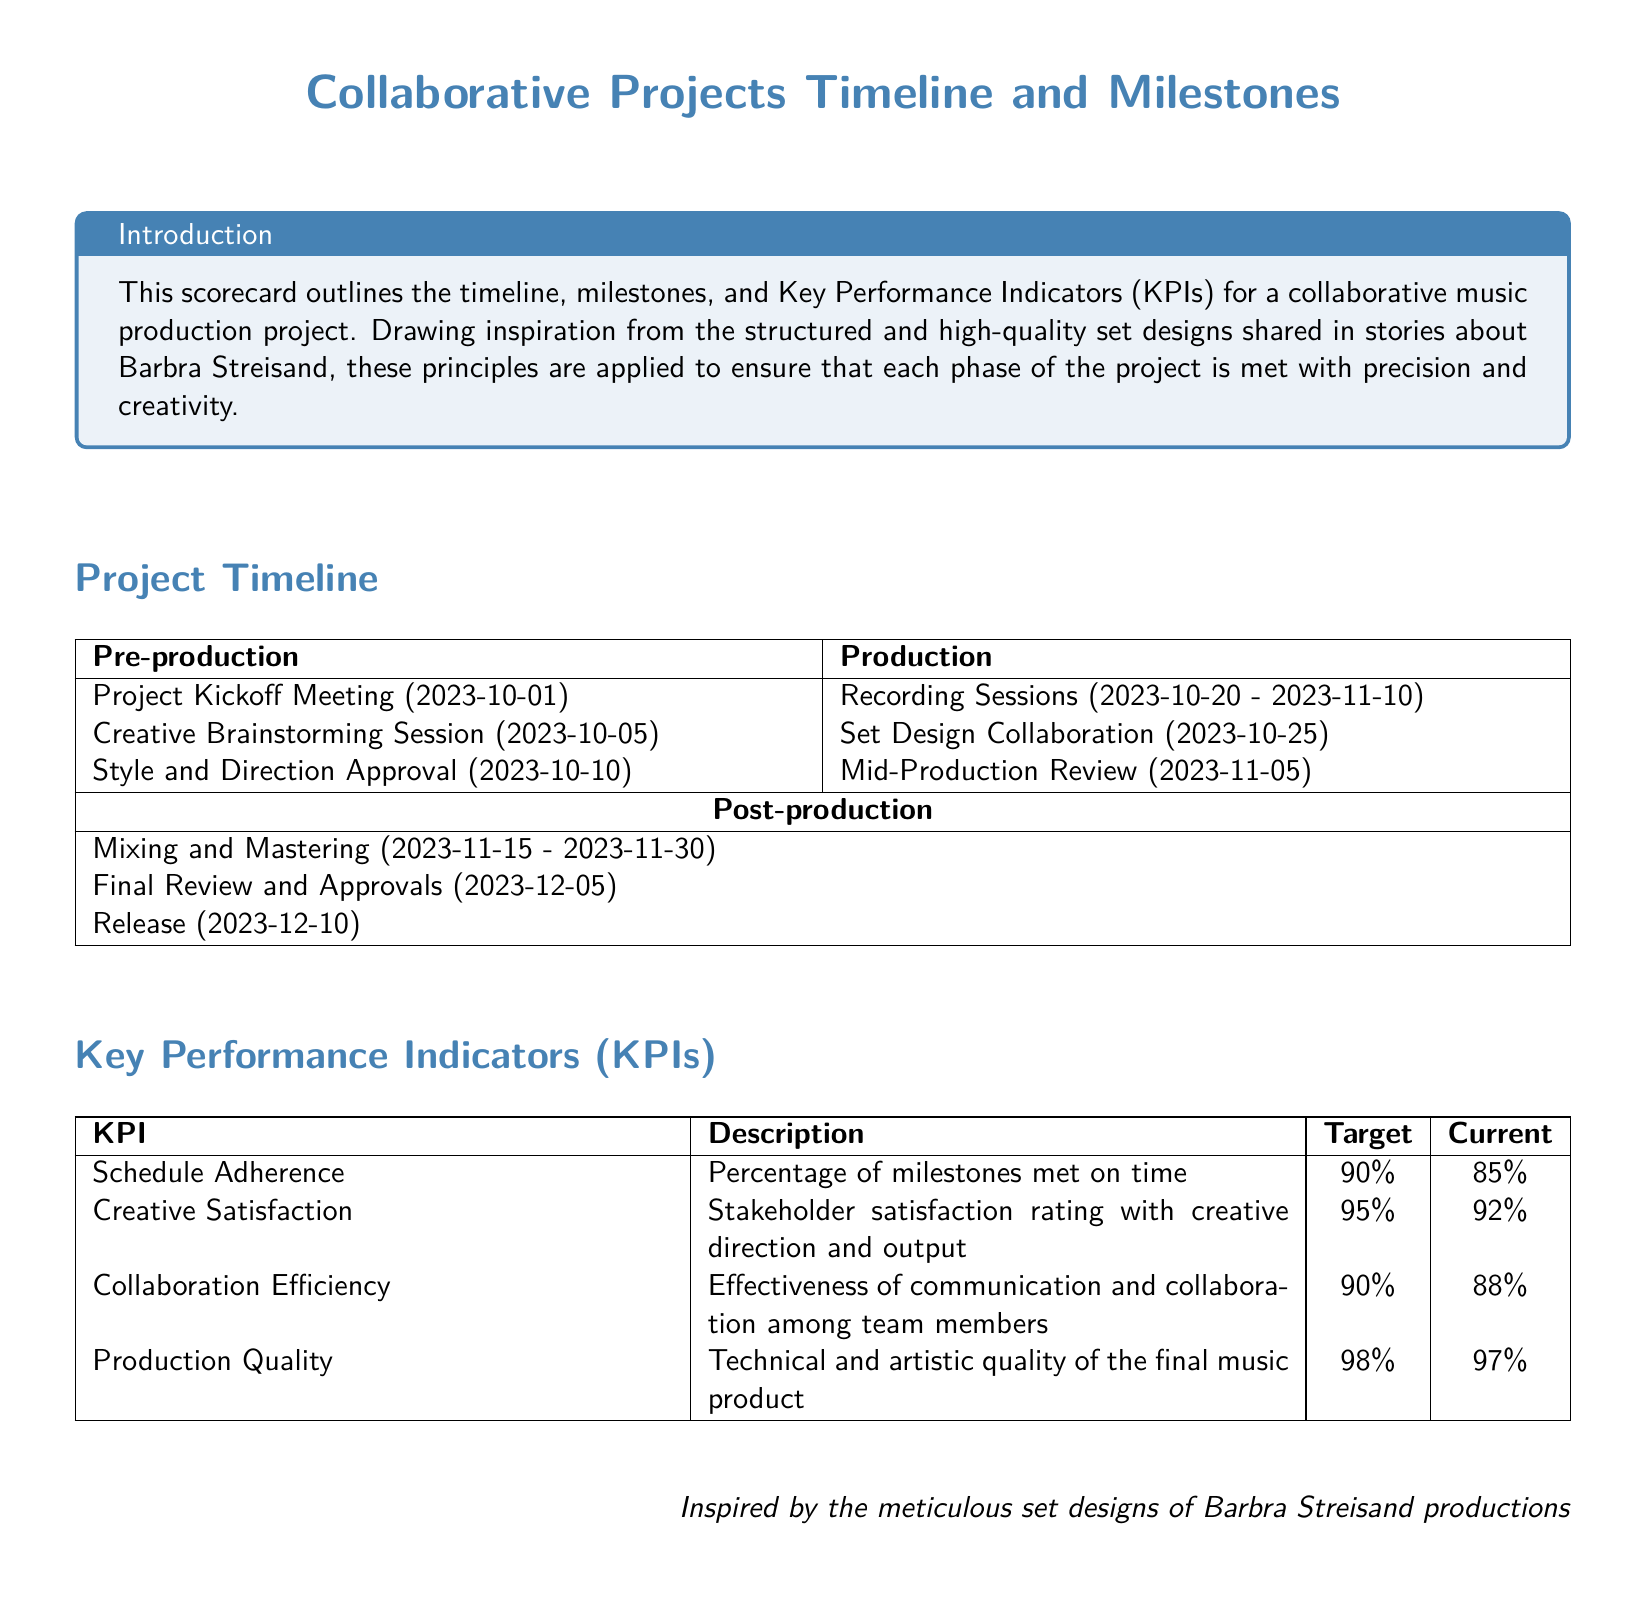What is the date of the project kickoff meeting? The date for the project kickoff meeting is specified in the document.
Answer: 2023-10-01 What phase follows the pre-production phase? The document outlines the sequence of phases in the project timeline, showing that after pre-production comes production.
Answer: Production What is the target percentage for schedule adherence? The target percentage for schedule adherence is listed in the KPI table of the document.
Answer: 90% What is the current creative satisfaction percentage? The current creative satisfaction percentage is found in the KPIs section of the document.
Answer: 92% When is the final review and approvals scheduled? The document contains specific dates for all major milestones, including this one.
Answer: 2023-12-05 How many recording sessions are planned? The document provides a timeframe for recording sessions but does not specify the number, requiring reasoning from the date range.
Answer: Unknown What is the target production quality percentage? The target production quality percentage is provided in the Key Performance Indicators section of the document.
Answer: 98% What is the purpose of the introduction section? The introduction outlines the intention of the scorecard regarding the collaborative music production project.
Answer: Outline the timeline, milestones, and KPIs Who is the inspiration behind the scorecard design? The document mentions an inspiration source at the end, providing context for the design approach.
Answer: Barbra Streisand 